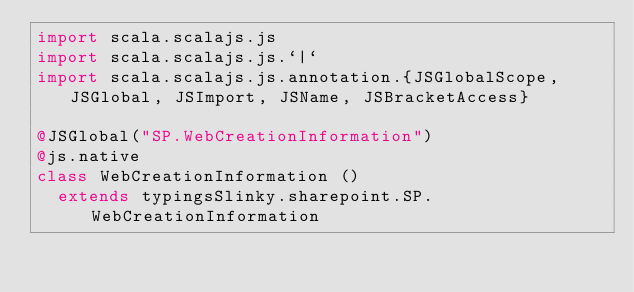<code> <loc_0><loc_0><loc_500><loc_500><_Scala_>import scala.scalajs.js
import scala.scalajs.js.`|`
import scala.scalajs.js.annotation.{JSGlobalScope, JSGlobal, JSImport, JSName, JSBracketAccess}

@JSGlobal("SP.WebCreationInformation")
@js.native
class WebCreationInformation ()
  extends typingsSlinky.sharepoint.SP.WebCreationInformation
</code> 